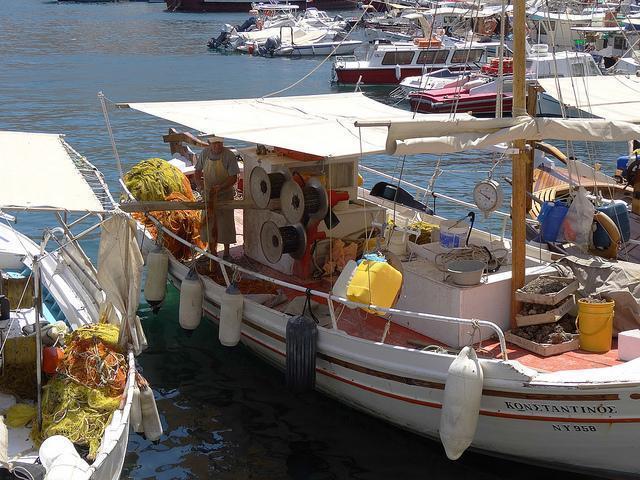What sort of method is used to secure these vessels to the shore?
Choose the right answer from the provided options to respond to the question.
Options: Knots, oars, motors, dolphins. Knots. 